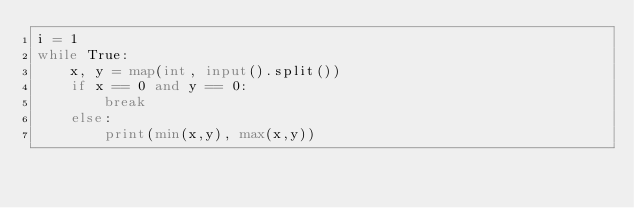<code> <loc_0><loc_0><loc_500><loc_500><_Python_>i = 1
while True:
    x, y = map(int, input().split())
    if x == 0 and y == 0:
        break
    else:
        print(min(x,y), max(x,y))
</code> 